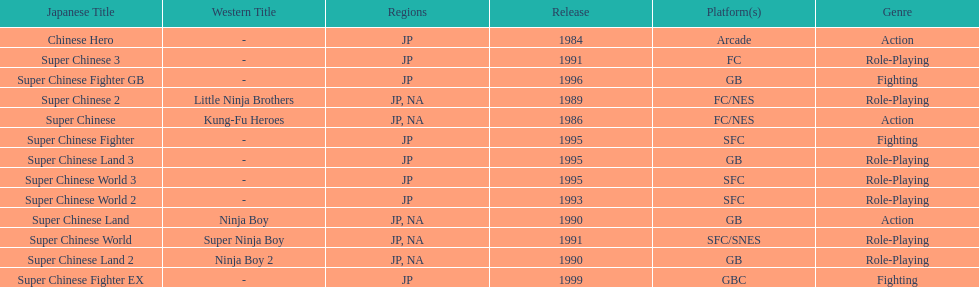Which platforms had the most titles released? GB. 